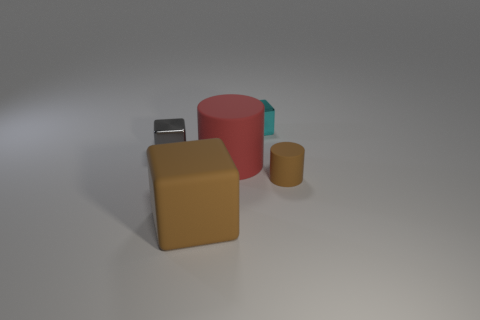How many other things are the same shape as the tiny brown rubber thing? 1 